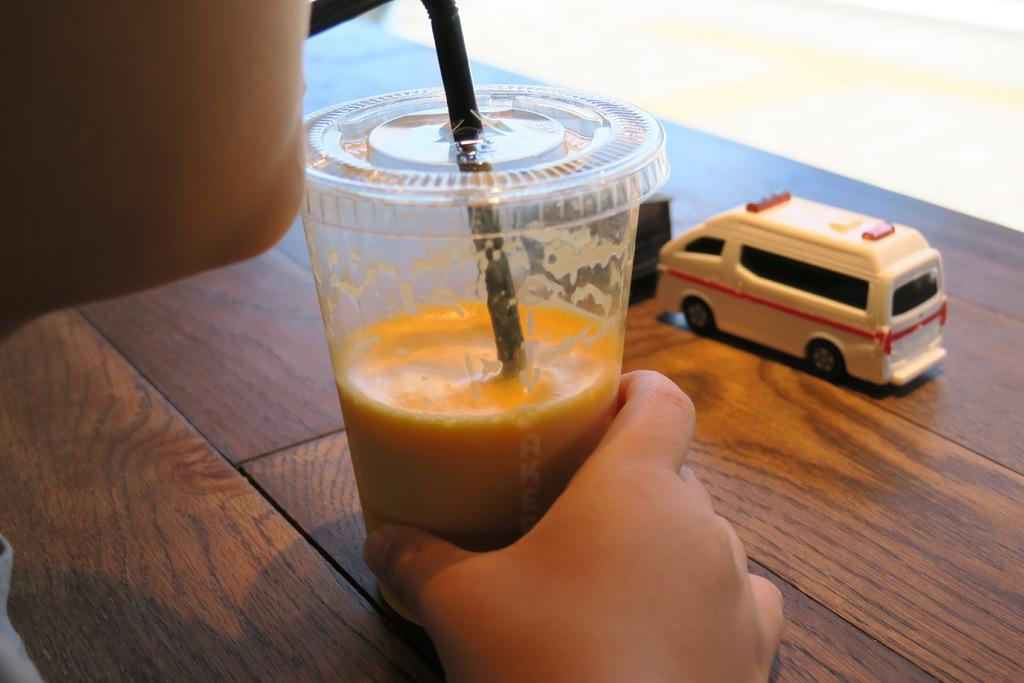What is in the glass that is visible in the image? There is liquid in the glass. What else can be seen in the image besides the glass? A human hand and a toy car on a brown table are visible in the image. What is the color of the table in the image? The table is brown in color. What type of fowl is sitting on the table in the image? There is no fowl present in the image; it only features a glass with liquid, a human hand, a toy car, and a brown table. 